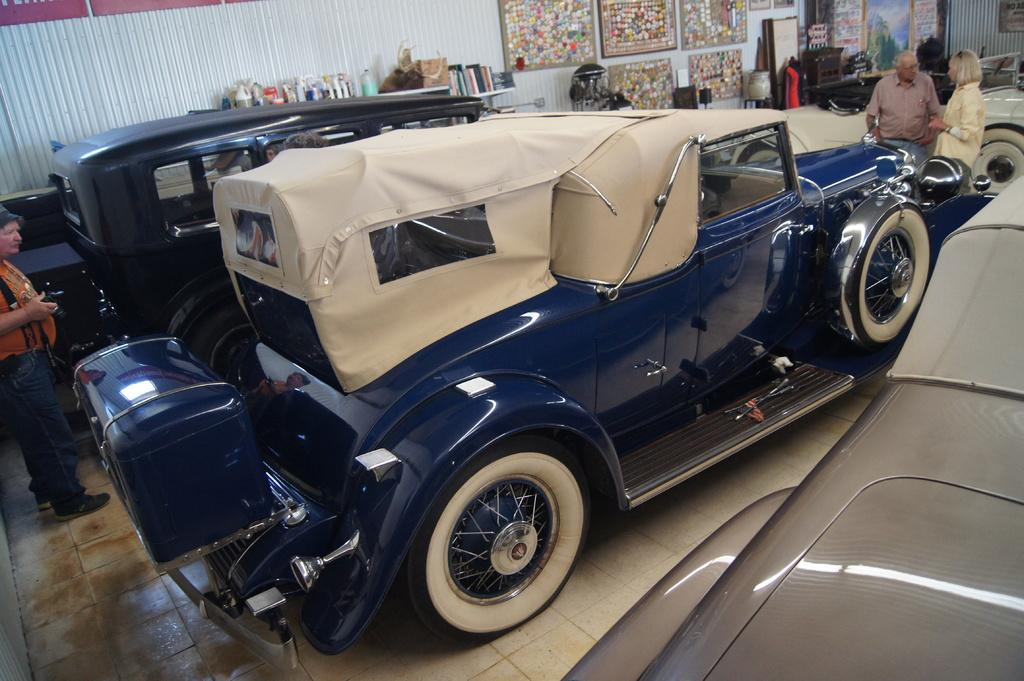What types of vehicles are present in the shed? There are different types of cars in the shed. What structural feature do the cars have? The cars have frames. Are there any people present in the shed? Yes, there are persons standing near the cars. How does the coast affect the grip of the cars in the image? There is no coast present in the image, as it features cars in a shed. 